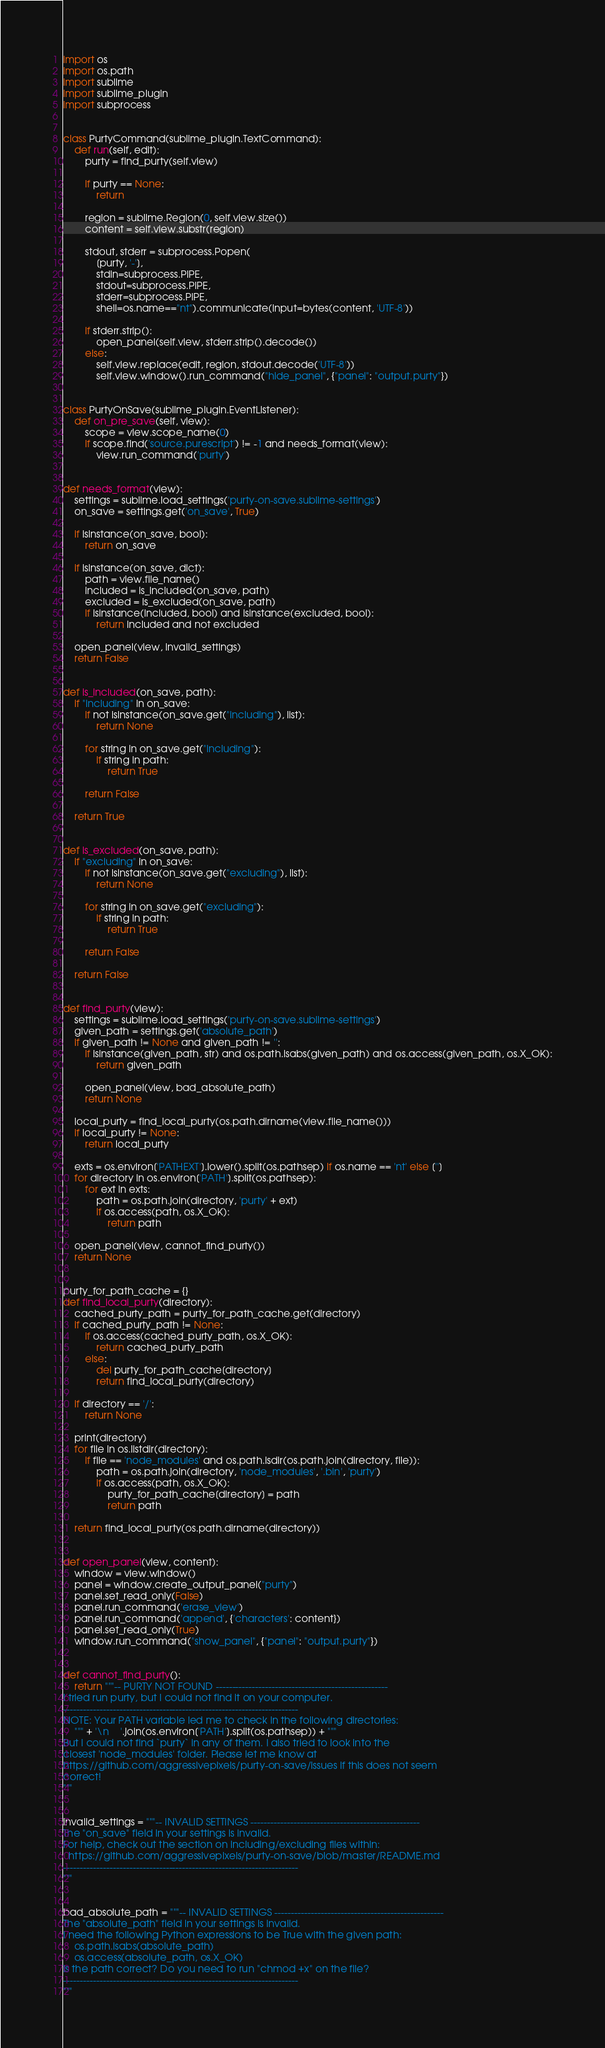Convert code to text. <code><loc_0><loc_0><loc_500><loc_500><_Python_>import os
import os.path
import sublime
import sublime_plugin
import subprocess


class PurtyCommand(sublime_plugin.TextCommand):
    def run(self, edit):
        purty = find_purty(self.view)

        if purty == None:
            return

        region = sublime.Region(0, self.view.size())
        content = self.view.substr(region)

        stdout, stderr = subprocess.Popen(
            [purty, '-'],
            stdin=subprocess.PIPE,
            stdout=subprocess.PIPE,
            stderr=subprocess.PIPE,
            shell=os.name=="nt").communicate(input=bytes(content, 'UTF-8'))

        if stderr.strip():
            open_panel(self.view, stderr.strip().decode())
        else:
            self.view.replace(edit, region, stdout.decode('UTF-8'))
            self.view.window().run_command("hide_panel", {"panel": "output.purty"})


class PurtyOnSave(sublime_plugin.EventListener):
    def on_pre_save(self, view):
        scope = view.scope_name(0)
        if scope.find('source.purescript') != -1 and needs_format(view):
            view.run_command('purty')


def needs_format(view):
    settings = sublime.load_settings('purty-on-save.sublime-settings')
    on_save = settings.get('on_save', True)

    if isinstance(on_save, bool):
        return on_save

    if isinstance(on_save, dict):
        path = view.file_name()
        included = is_included(on_save, path)
        excluded = is_excluded(on_save, path)
        if isinstance(included, bool) and isinstance(excluded, bool):
            return included and not excluded

    open_panel(view, invalid_settings)
    return False


def is_included(on_save, path):
    if "including" in on_save:
        if not isinstance(on_save.get("including"), list):
            return None

        for string in on_save.get("including"):
            if string in path:
                return True

        return False

    return True


def is_excluded(on_save, path):
    if "excluding" in on_save:
        if not isinstance(on_save.get("excluding"), list):
            return None

        for string in on_save.get("excluding"):
            if string in path:
                return True

        return False

    return False


def find_purty(view):
    settings = sublime.load_settings('purty-on-save.sublime-settings')
    given_path = settings.get('absolute_path')
    if given_path != None and given_path != '':
        if isinstance(given_path, str) and os.path.isabs(given_path) and os.access(given_path, os.X_OK):
            return given_path

        open_panel(view, bad_absolute_path)
        return None

    local_purty = find_local_purty(os.path.dirname(view.file_name()))
    if local_purty != None:
        return local_purty
    
    exts = os.environ['PATHEXT'].lower().split(os.pathsep) if os.name == 'nt' else ['']
    for directory in os.environ['PATH'].split(os.pathsep):
        for ext in exts:
            path = os.path.join(directory, 'purty' + ext)
            if os.access(path, os.X_OK):
                return path

    open_panel(view, cannot_find_purty())
    return None


purty_for_path_cache = {}
def find_local_purty(directory):
    cached_purty_path = purty_for_path_cache.get(directory)
    if cached_purty_path != None:
        if os.access(cached_purty_path, os.X_OK):
            return cached_purty_path
        else:
            del purty_for_path_cache[directory]
            return find_local_purty(directory)

    if directory == '/':
        return None

    print(directory)
    for file in os.listdir(directory):
        if file == 'node_modules' and os.path.isdir(os.path.join(directory, file)):
            path = os.path.join(directory, 'node_modules', '.bin', 'purty')
            if os.access(path, os.X_OK):
                purty_for_path_cache[directory] = path
                return path

    return find_local_purty(os.path.dirname(directory))


def open_panel(view, content):
    window = view.window()
    panel = window.create_output_panel("purty")
    panel.set_read_only(False)
    panel.run_command('erase_view')
    panel.run_command('append', {'characters': content})
    panel.set_read_only(True)
    window.run_command("show_panel", {"panel": "output.purty"})


def cannot_find_purty():
    return """-- PURTY NOT FOUND ----------------------------------------------------
I tried run purty, but I could not find it on your computer.
-----------------------------------------------------------------------
NOTE: Your PATH variable led me to check in the following directories:
    """ + '\n    '.join(os.environ['PATH'].split(os.pathsep)) + """
But I could not find `purty` in any of them. I also tried to look into the
closest 'node_modules' folder. Please let me know at 
https://github.com/aggressivepixels/purty-on-save/issues if this does not seem 
correct!
"""


invalid_settings = """-- INVALID SETTINGS ---------------------------------------------------
The "on_save" field in your settings is invalid.
For help, check out the section on including/excluding files within:
  https://github.com/aggressivepixels/purty-on-save/blob/master/README.md
-----------------------------------------------------------------------
"""


bad_absolute_path = """-- INVALID SETTINGS ---------------------------------------------------
The "absolute_path" field in your settings is invalid.
I need the following Python expressions to be True with the given path:
    os.path.isabs(absolute_path)
    os.access(absolute_path, os.X_OK)
Is the path correct? Do you need to run "chmod +x" on the file?
-----------------------------------------------------------------------
"""
</code> 